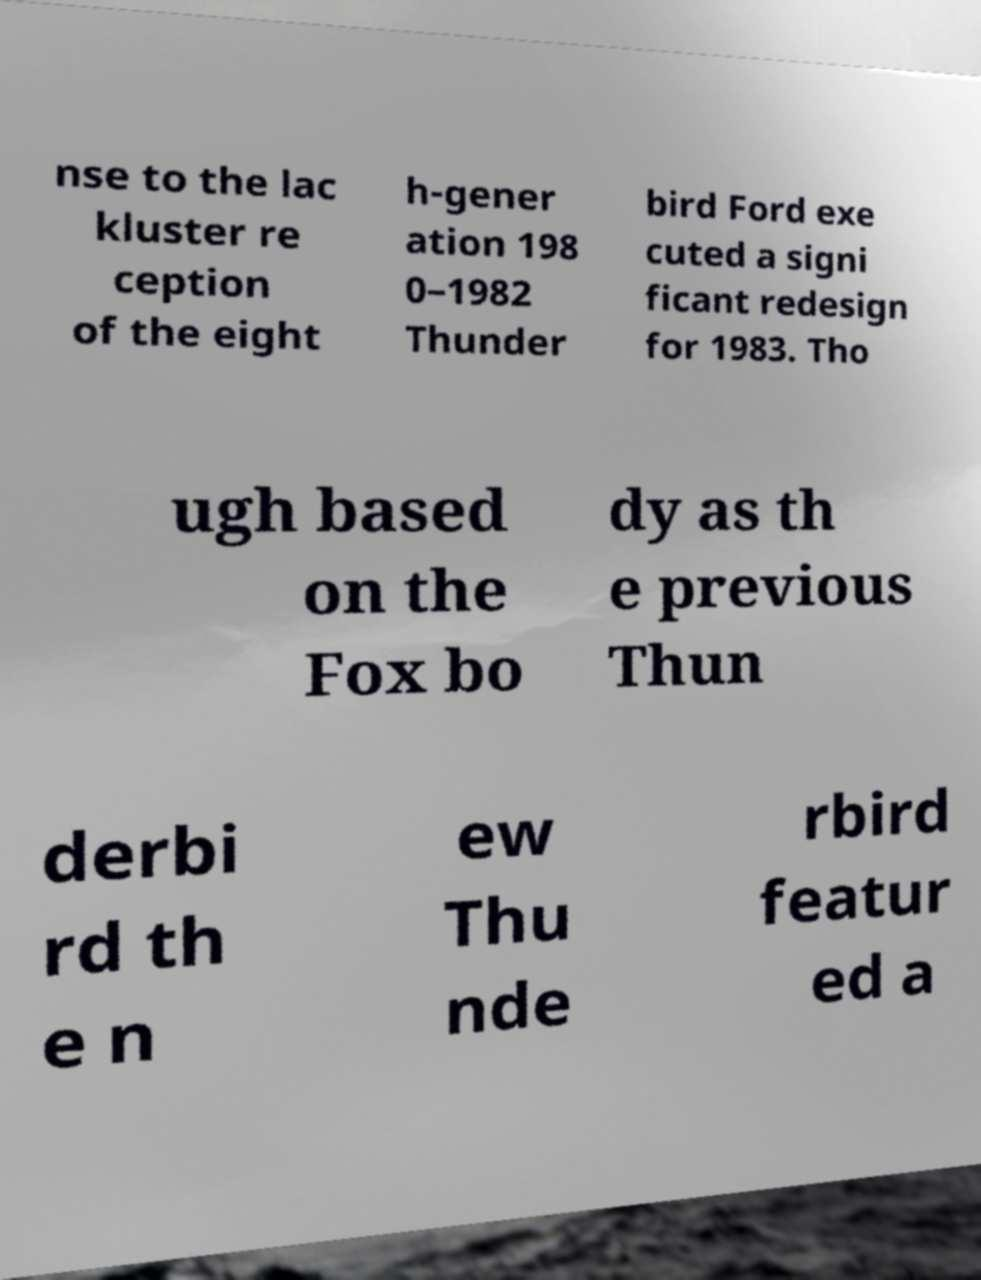Please read and relay the text visible in this image. What does it say? nse to the lac kluster re ception of the eight h-gener ation 198 0–1982 Thunder bird Ford exe cuted a signi ficant redesign for 1983. Tho ugh based on the Fox bo dy as th e previous Thun derbi rd th e n ew Thu nde rbird featur ed a 